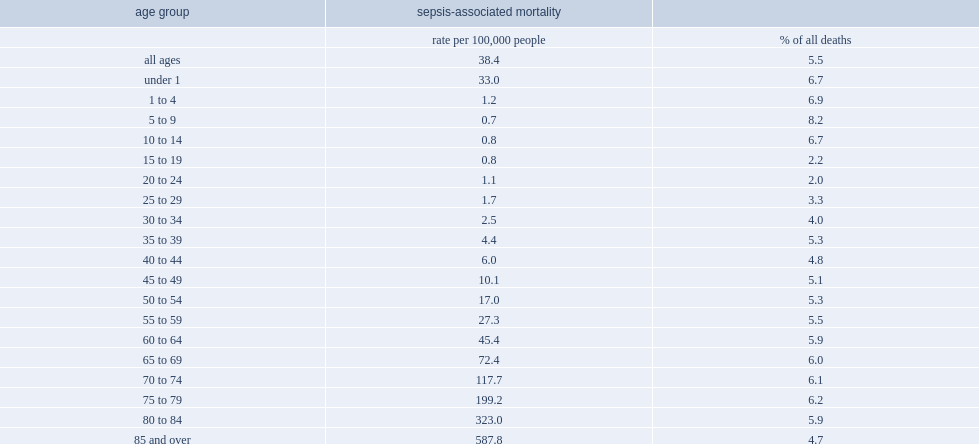How many deaths involving sepsis among the oldest age group (85 and older) per 100,000 from 2009 to 2011? 587.8. How many deaths involving sepsis among the ages 5 and 9 per 100,000 from 2009 to 2011? 0.7. How many deaths involving sepsis among the ages 10 and 14 per 100,000 from 2009 to 2011? 0.8. How many deaths involving sepsis of infants under the age of 1 per 100,000 from 2009 to 2011? 33.0. What is the percentage among children (those who died before the age of 10 to 14) sepsis from 2009 to 2011? 6.7. What is the percentage among children (those who died before the age of 5 to 9) sepsis from 2009 to 2011? 8.2. Adolescents and young adults (ages 20 to 24) were the least likely to have sepsis contribute to their deaths, with what percentage of all deaths involving sepsis from 2009 to 2011? 2.0. Adolescents and young adults (ages 25 to 29) were the least likely to have sepsis contribute to their deaths, with what percentage of all deaths involving sepsis from 2009 to 2011? 3.3. 